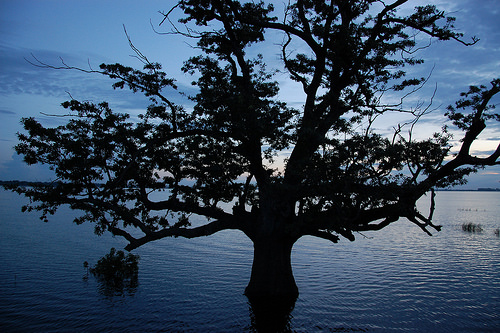<image>
Can you confirm if the tree is next to the water? No. The tree is not positioned next to the water. They are located in different areas of the scene. Is there a tree above the water? Yes. The tree is positioned above the water in the vertical space, higher up in the scene. 